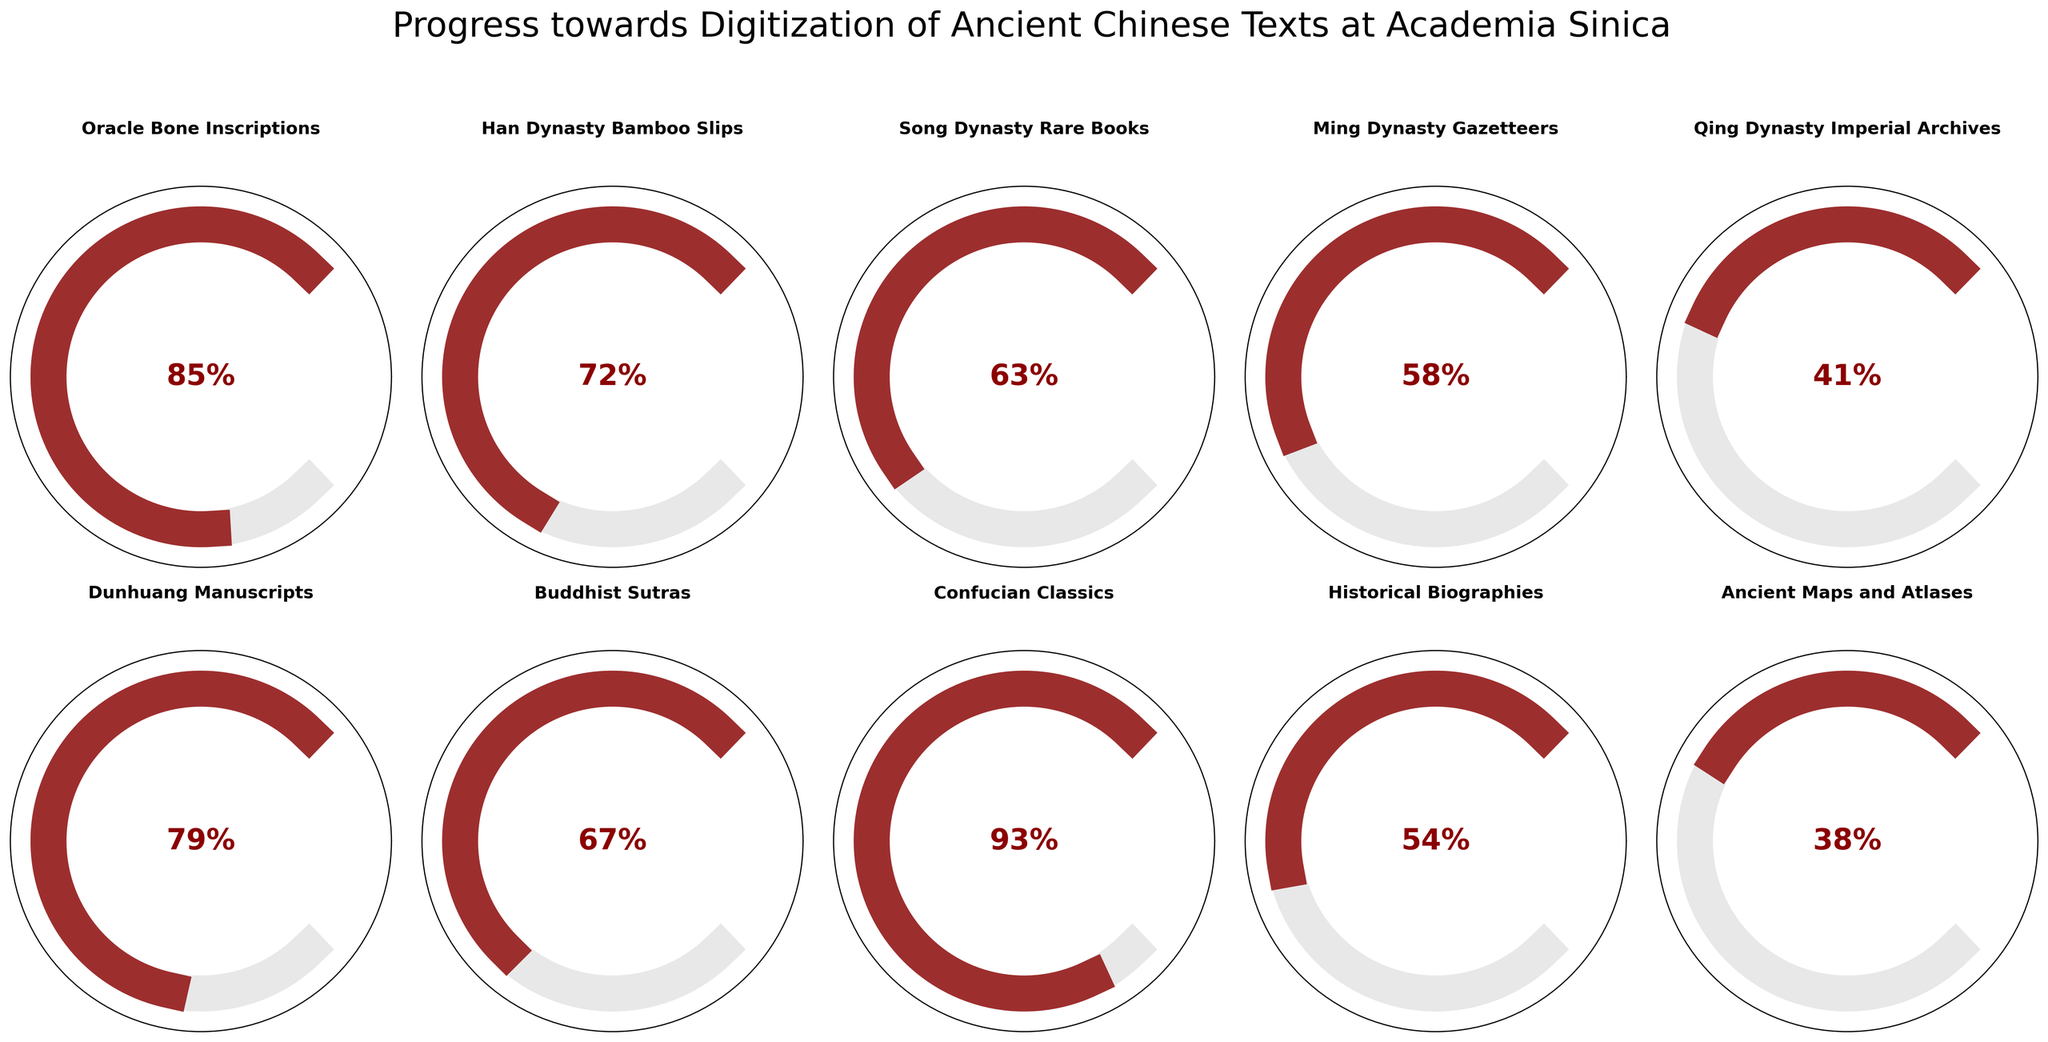What is the title of the figure? The title of the figure is placed at the top and reads "Progress towards Digitization of Ancient Chinese Texts at Academia Sinica".
Answer: Progress towards Digitization of Ancient Chinese Texts at Academia Sinica What category has the highest digitization progress? By inspecting the red arcs of each gauge, the category with the highest digitization progress is "Confucian Classics" at 93%.
Answer: Confucian Classics Which category has the lowest progress percentage? The category with the smallest red arc, indicating the lowest progress, is "Ancient Maps and Atlases" at 38%.
Answer: Ancient Maps and Atlases How many categories have a digitization progress greater than 70%? By looking at the percentages, the categories with progress greater than 70% are "Oracle Bone Inscriptions" (85%), "Han Dynasty Bamboo Slips" (72%), "Dunhuang Manuscripts" (79%), and "Confucian Classics" (93%). There are 4 such categories.
Answer: 4 What is the combined digitization progress of "Ming Dynasty Gazetteers" and "Qing Dynasty Imperial Archives"? To find the combined progress, add the percentages of the two categories: 58% (Ming Dynasty Gazetteers) + 41% (Qing Dynasty Imperial Archives) = 99%.
Answer: 99% Which category's digitization progress is closest to the median value overall? First, list the progress values: 85, 72, 63, 58, 41, 79, 67, 93, 54, 38. Sorting these values: 38, 41, 54, 58, 63, 67, 72, 79, 85, 93. The median value is the average of the 5th and 6th values: (63 + 67) / 2 = 65. The category closest to 65 is "Buddhist Sutras" at 67%.
Answer: Buddhist Sutras What is the average digitization progress across all categories? Sum all the progress values and divide by the number of categories: (85 + 72 + 63 + 58 + 41 + 79 + 67 + 93 + 54 + 38) / 10 = 65%.
Answer: 65% Which category has more digitization progress, "Song Dynasty Rare Books" or "Historical Biographies"? By comparing the progress values, "Song Dynasty Rare Books" has 63% whereas "Historical Biographies" has 54%. Therefore, "Song Dynasty Rare Books" has more progress.
Answer: Song Dynasty Rare Books Is the digitization progress for "Dunhuang Manuscripts" more than double that of "Ancient Maps and Atlases"? "Dunhuang Manuscripts" have a progress of 79% and "Ancient Maps and Atlases" have 38%. Double of 38% is 76%, and since 79% > 76%, it is more than double.
Answer: Yes What is the difference in digitization progress between "Han Dynasty Bamboo Slips" and "Qing Dynasty Imperial Archives"? Subtract the progress of the "Qing Dynasty Imperial Archives" from the "Han Dynasty Bamboo Slips": 72% - 41% = 31%.
Answer: 31% 